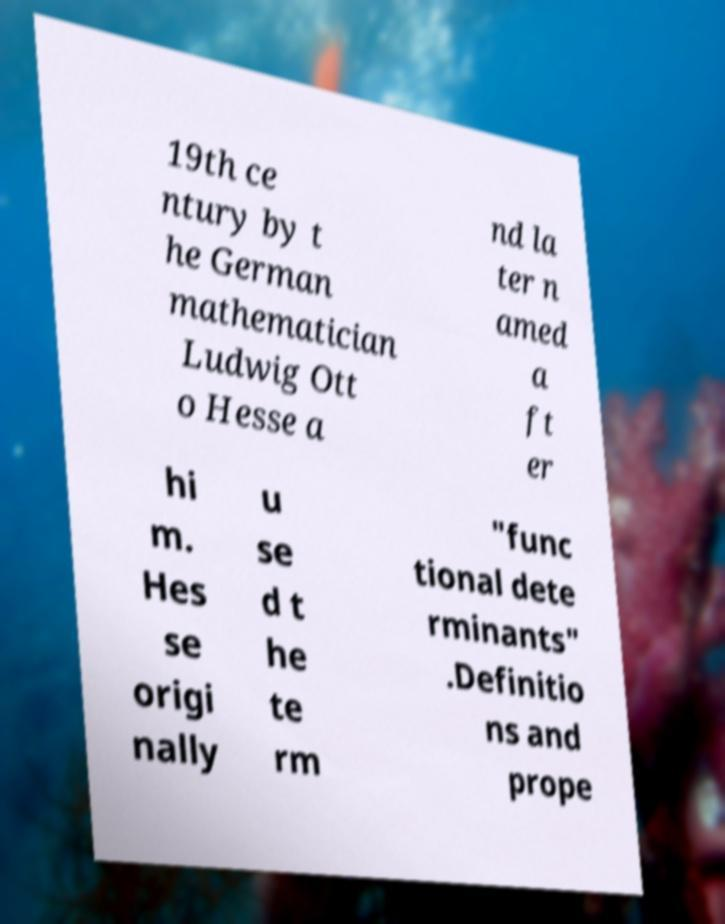For documentation purposes, I need the text within this image transcribed. Could you provide that? 19th ce ntury by t he German mathematician Ludwig Ott o Hesse a nd la ter n amed a ft er hi m. Hes se origi nally u se d t he te rm "func tional dete rminants" .Definitio ns and prope 